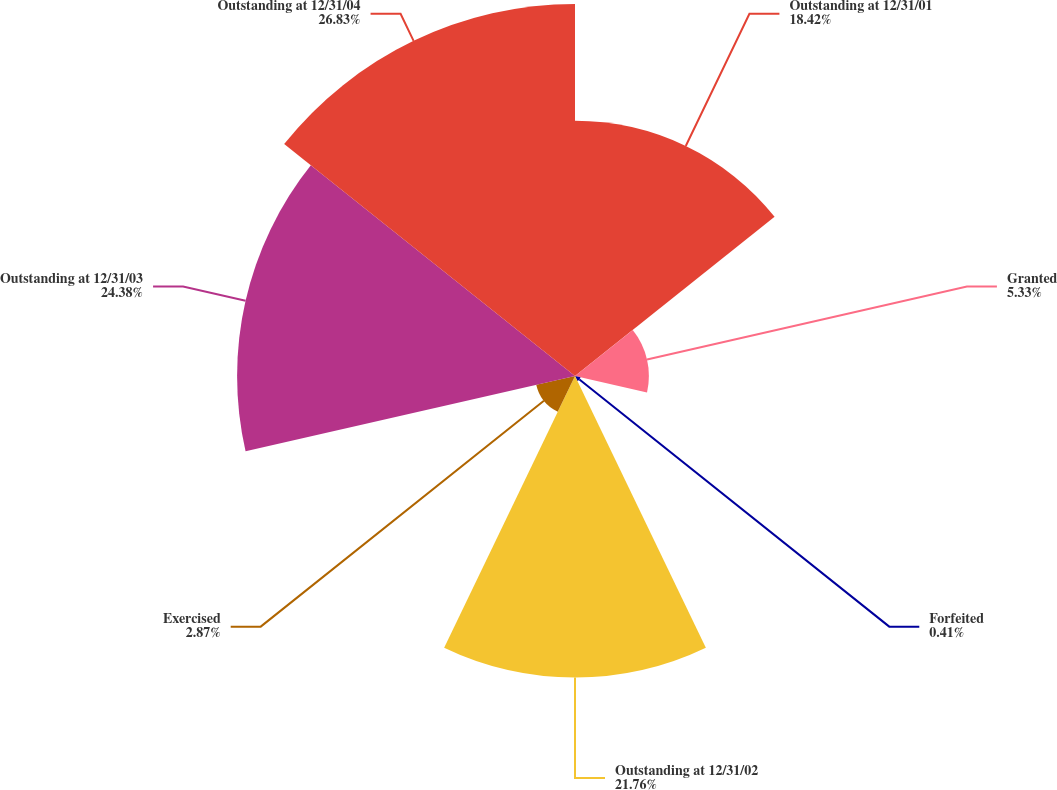<chart> <loc_0><loc_0><loc_500><loc_500><pie_chart><fcel>Outstanding at 12/31/01<fcel>Granted<fcel>Forfeited<fcel>Outstanding at 12/31/02<fcel>Exercised<fcel>Outstanding at 12/31/03<fcel>Outstanding at 12/31/04<nl><fcel>18.42%<fcel>5.33%<fcel>0.41%<fcel>21.76%<fcel>2.87%<fcel>24.38%<fcel>26.84%<nl></chart> 